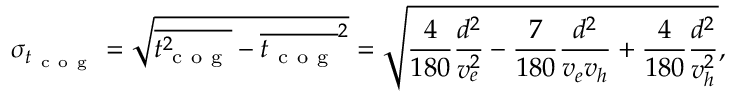Convert formula to latex. <formula><loc_0><loc_0><loc_500><loc_500>\sigma _ { { t _ { c o g } } } = \sqrt { \overline { { t _ { c o g } ^ { 2 } } } - \overline { { t _ { c o g } } } ^ { 2 } } = \sqrt { \frac { 4 } { 1 8 0 } \frac { d ^ { 2 } } { v _ { e } ^ { 2 } } - \frac { 7 } { 1 8 0 } \frac { d ^ { 2 } } { v _ { e } v _ { h } } + \frac { 4 } { 1 8 0 } \frac { d ^ { 2 } } { v _ { h } ^ { 2 } } } ,</formula> 